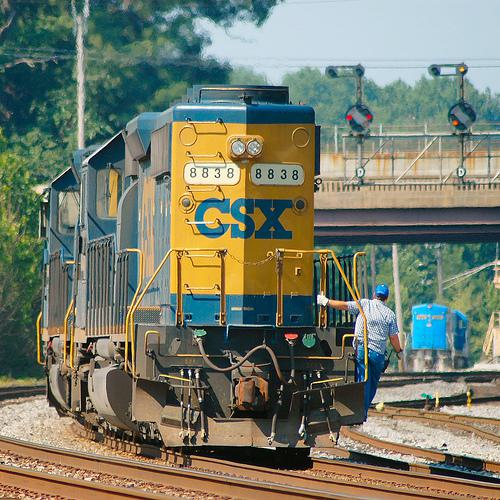How many trains would there be in the image if one additional train was added in the scence? 3 